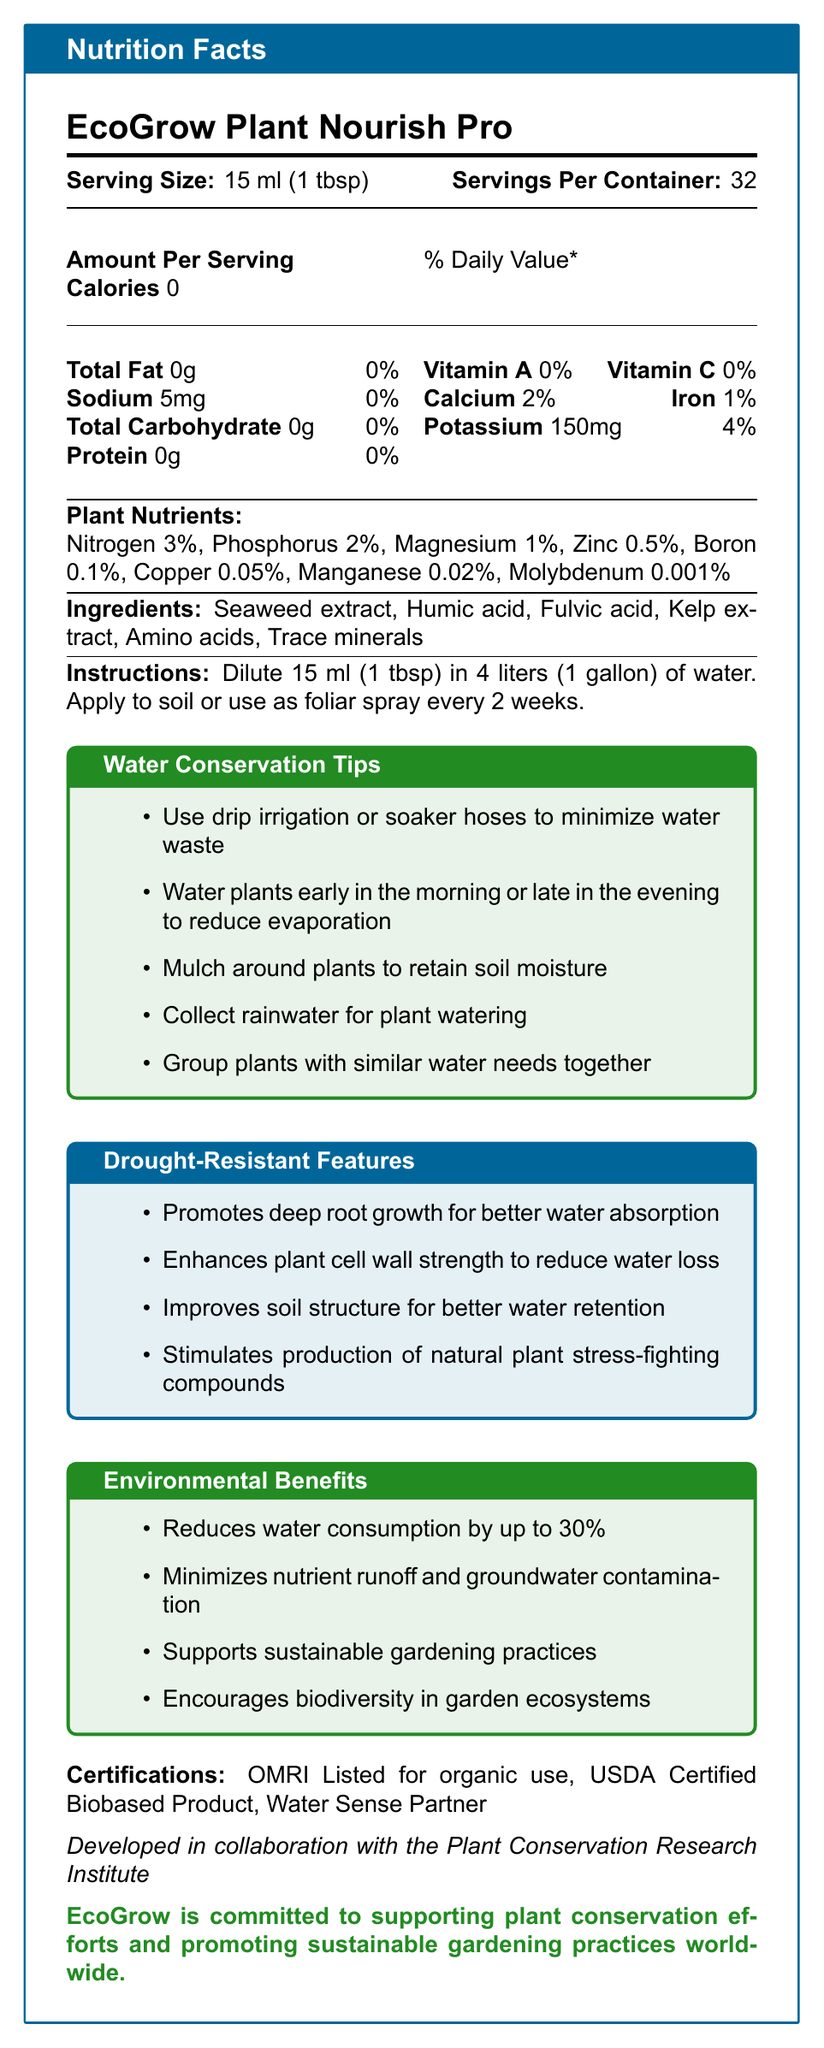what is the product name? The product name is shown at the top of the Nutrition Facts document.
Answer: EcoGrow Plant Nourish Pro what is the serving size? The serving size is listed as 15 ml (1 tbsp) in the document.
Answer: 15 ml (1 tbsp) how many servings are in one container? The document states that there are 32 servings per container.
Answer: 32 how many calories are in a serving? The document specifies that there are 0 calories per serving.
Answer: 0 how much sodium is in a serving? The document lists 5mg of sodium per serving.
Answer: 5mg what percentage of daily value of calcium does one serving provide? The document shows that one serving provides 2% of the daily value of calcium.
Answer: 2% which of the following is not listed as an ingredient? A. Seaweed extract B. Humic acid C. Phosphorus D. Amino acids The ingredients list includes Seaweed extract, Humic acid, and Amino acids, but not Phosphorus.
Answer: C. Phosphorus what is the amount of potassium per serving? A. 100mg B. 150mg C. 200mg D. 250mg The document lists 150mg of potassium per serving.
Answer: B. 150mg does the product contain any carbohydrates? The document states that the total carbohydrate content is 0g.
Answer: No is EcoGrow Plant Nourish Pro OMRI Listed for organic use? The document lists OMRI Listed for organic use under certifications.
Answer: Yes describe the main idea of the document. The document contains various sections covering different aspects of the product, from nutritional facts to sustainability features, giving a comprehensive overview.
Answer: The document provides detailed nutritional information, usage instructions, water conservation tips, drought-resistant features, environmental benefits, and certifications for the product EcoGrow Plant Nourish Pro. what are some water conservation tips mentioned for using EcoGrow Plant Nourish Pro? The document lists several water conservation tips including using drip irrigation, watering at specific times, mulching, collecting rainwater, and grouping similar plants together.
Answer: Use drip irrigation or soaker hoses, Water plants early in the morning or late in the evening, Mulch around plants, Collect rainwater, Group plants with similar water needs together. who collaborated in the development of EcoGrow Plant Nourish Pro? The document mentions that EcoGrow Plant Nourish Pro was developed in collaboration with the Plant Conservation Research Institute.
Answer: Plant Conservation Research Institute what are the drought-resistant features of EcoGrow Plant Nourish Pro? The document highlights that the product promotes deep root growth, enhances plant cell wall strength, improves soil structure, and stimulates natural stress-fighting compounds in plants.
Answer: Promotes deep root growth, Enhances plant cell wall strength, Improves soil structure, Stimulates production of natural plant stress-fighting compounds. how often should EcoGrow Plant Nourish Pro be applied? The instructions state that the product should be applied every 2 weeks.
Answer: Every 2 weeks what is the percentage of iron in one serving? The document states that one serving contains 1% of the daily iron value.
Answer: 1% what ingredient is listed first in the ingredients list? The first ingredient listed in the document is Seaweed extract.
Answer: Seaweed extract which of the following certifications does EcoGrow Plant Nourish Pro have? A. USDA Certified Organic B. Water Sense Partner C. EPA Safer Choice D. Organic Food Product Among the listed options, the correct certification from the document is Water Sense Partner.
Answer: B. Water Sense Partner what is the recommended dilution for using EcoGrow Plant Nourish Pro? The instructions specify diluting 15 ml (1 tbsp) of the product in 4 liters (1 gallon) of water.
Answer: 15 ml (1 tbsp) in 4 liters (1 gallon) of water how much nitrogen is in a serving of EcoGrow Plant Nourish Pro? The document mentions that there is 3% nitrogen in a serving.
Answer: 3% how much manganese is in a serving of EcoGrow Plant Nourish Pro? According to the document, each serving contains 0.02% manganese.
Answer: 0.02% how long has EcoGrow Plant Nourish Pro been on the market? The document does not provide any information regarding how long the product has been on the market.
Answer: Not enough information what are the environmental benefits of using EcoGrow Plant Nourish Pro? The document lists several environmental benefits including water conservation, reducing runoff, and supporting sustainable gardening practices.
Answer: Reduces water consumption by up to 30%, Minimizes nutrient runoff and groundwater contamination, Supports sustainable gardening practices, Encourages biodiversity in garden ecosystems. 